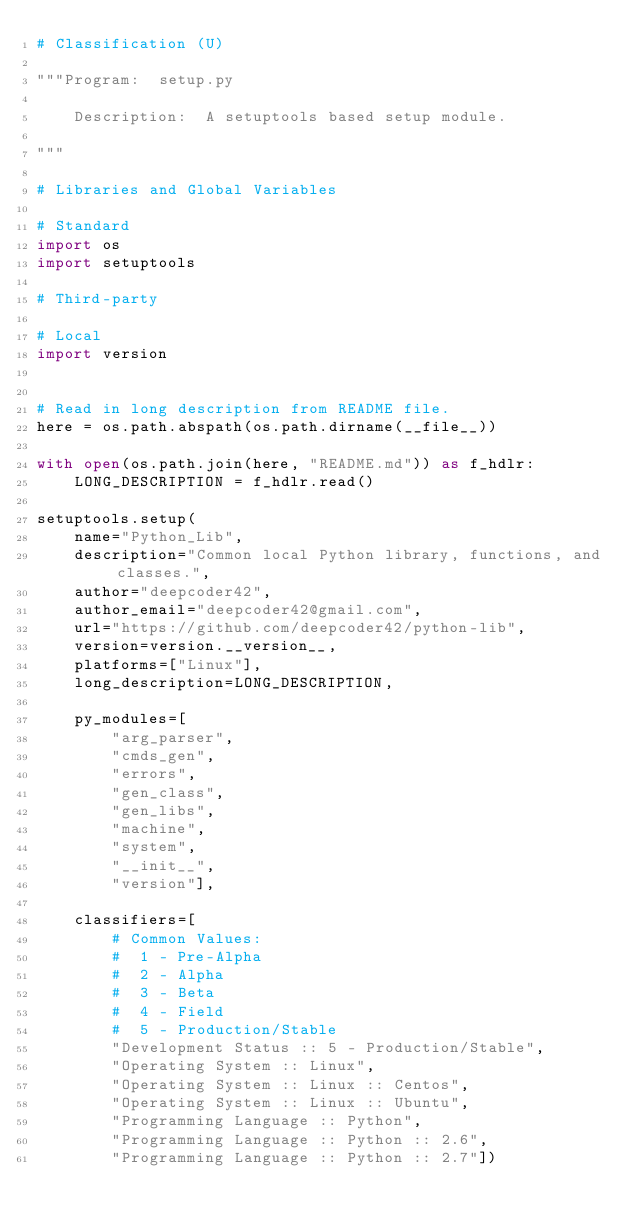<code> <loc_0><loc_0><loc_500><loc_500><_Python_># Classification (U)

"""Program:  setup.py

    Description:  A setuptools based setup module.

"""

# Libraries and Global Variables

# Standard
import os
import setuptools

# Third-party

# Local
import version


# Read in long description from README file.
here = os.path.abspath(os.path.dirname(__file__))

with open(os.path.join(here, "README.md")) as f_hdlr:
    LONG_DESCRIPTION = f_hdlr.read()

setuptools.setup(
    name="Python_Lib",
    description="Common local Python library, functions, and classes.",
    author="deepcoder42",
    author_email="deepcoder42@gmail.com",
    url="https://github.com/deepcoder42/python-lib",
    version=version.__version__,
    platforms=["Linux"],
    long_description=LONG_DESCRIPTION,

    py_modules=[
        "arg_parser",
        "cmds_gen",
        "errors",
        "gen_class",
        "gen_libs",
        "machine",
        "system",
        "__init__",
        "version"],

    classifiers=[
        # Common Values:
        #  1 - Pre-Alpha
        #  2 - Alpha
        #  3 - Beta
        #  4 - Field
        #  5 - Production/Stable
        "Development Status :: 5 - Production/Stable",
        "Operating System :: Linux",
        "Operating System :: Linux :: Centos",
        "Operating System :: Linux :: Ubuntu",
        "Programming Language :: Python",
        "Programming Language :: Python :: 2.6",
        "Programming Language :: Python :: 2.7"])
</code> 